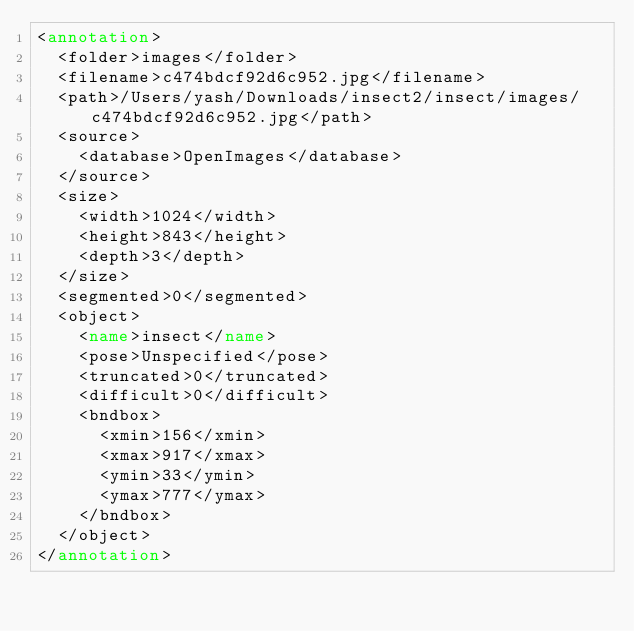<code> <loc_0><loc_0><loc_500><loc_500><_XML_><annotation>
  <folder>images</folder>
  <filename>c474bdcf92d6c952.jpg</filename>
  <path>/Users/yash/Downloads/insect2/insect/images/c474bdcf92d6c952.jpg</path>
  <source>
    <database>OpenImages</database>
  </source>
  <size>
    <width>1024</width>
    <height>843</height>
    <depth>3</depth>
  </size>
  <segmented>0</segmented>
  <object>
    <name>insect</name>
    <pose>Unspecified</pose>
    <truncated>0</truncated>
    <difficult>0</difficult>
    <bndbox>
      <xmin>156</xmin>
      <xmax>917</xmax>
      <ymin>33</ymin>
      <ymax>777</ymax>
    </bndbox>
  </object>
</annotation>
</code> 